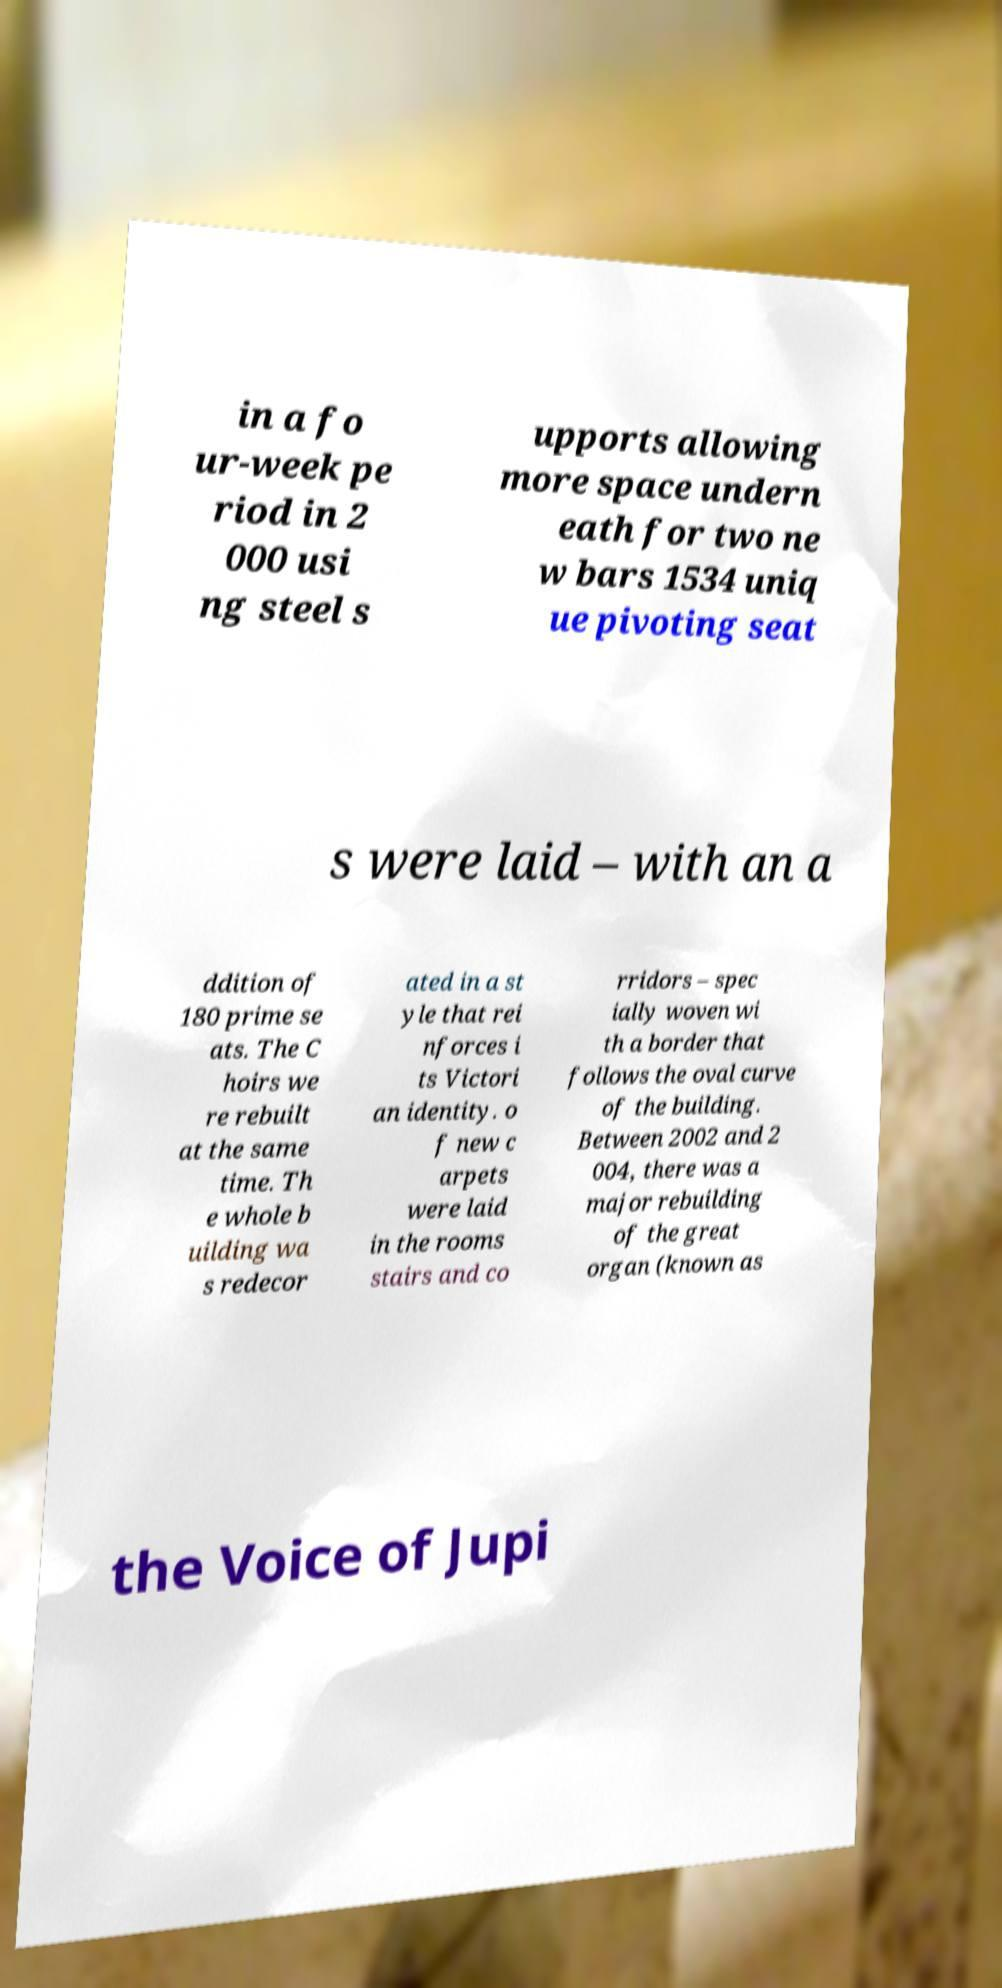Please read and relay the text visible in this image. What does it say? in a fo ur-week pe riod in 2 000 usi ng steel s upports allowing more space undern eath for two ne w bars 1534 uniq ue pivoting seat s were laid – with an a ddition of 180 prime se ats. The C hoirs we re rebuilt at the same time. Th e whole b uilding wa s redecor ated in a st yle that rei nforces i ts Victori an identity. o f new c arpets were laid in the rooms stairs and co rridors – spec ially woven wi th a border that follows the oval curve of the building. Between 2002 and 2 004, there was a major rebuilding of the great organ (known as the Voice of Jupi 